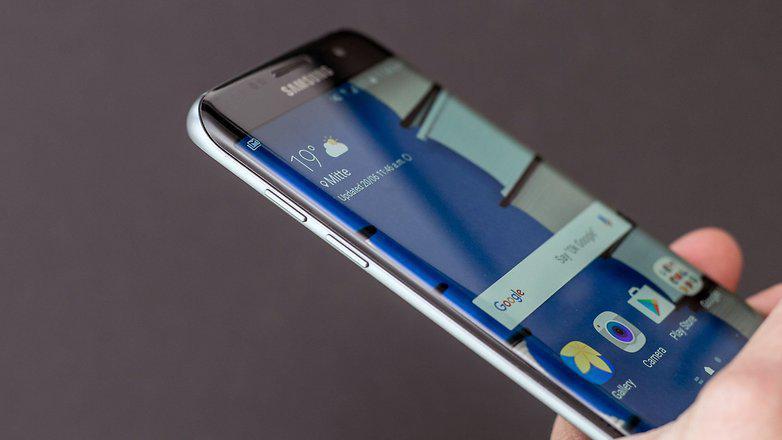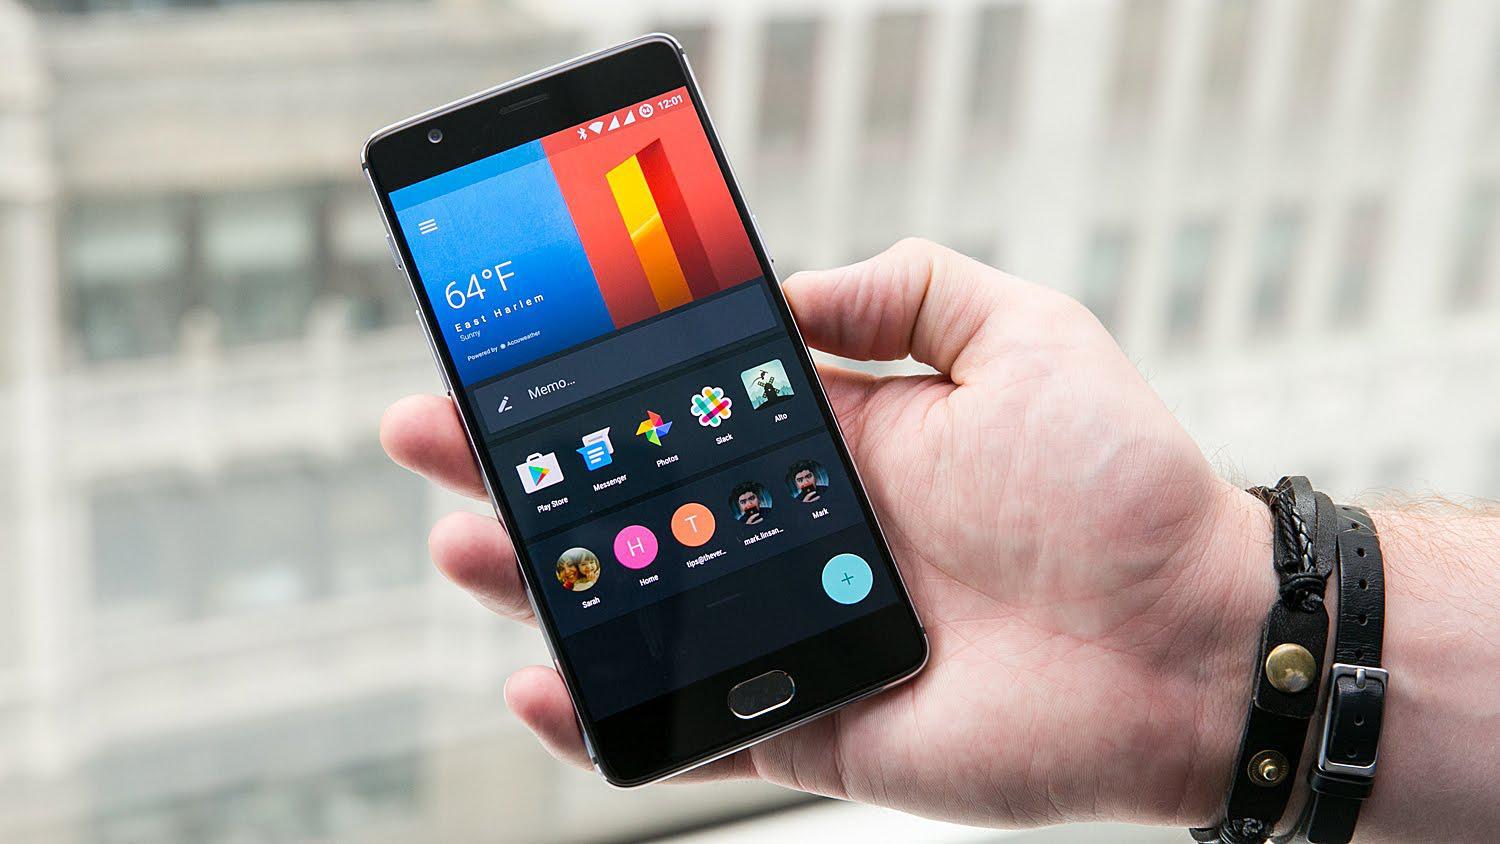The first image is the image on the left, the second image is the image on the right. Assess this claim about the two images: "There are three hands.". Correct or not? Answer yes or no. No. 